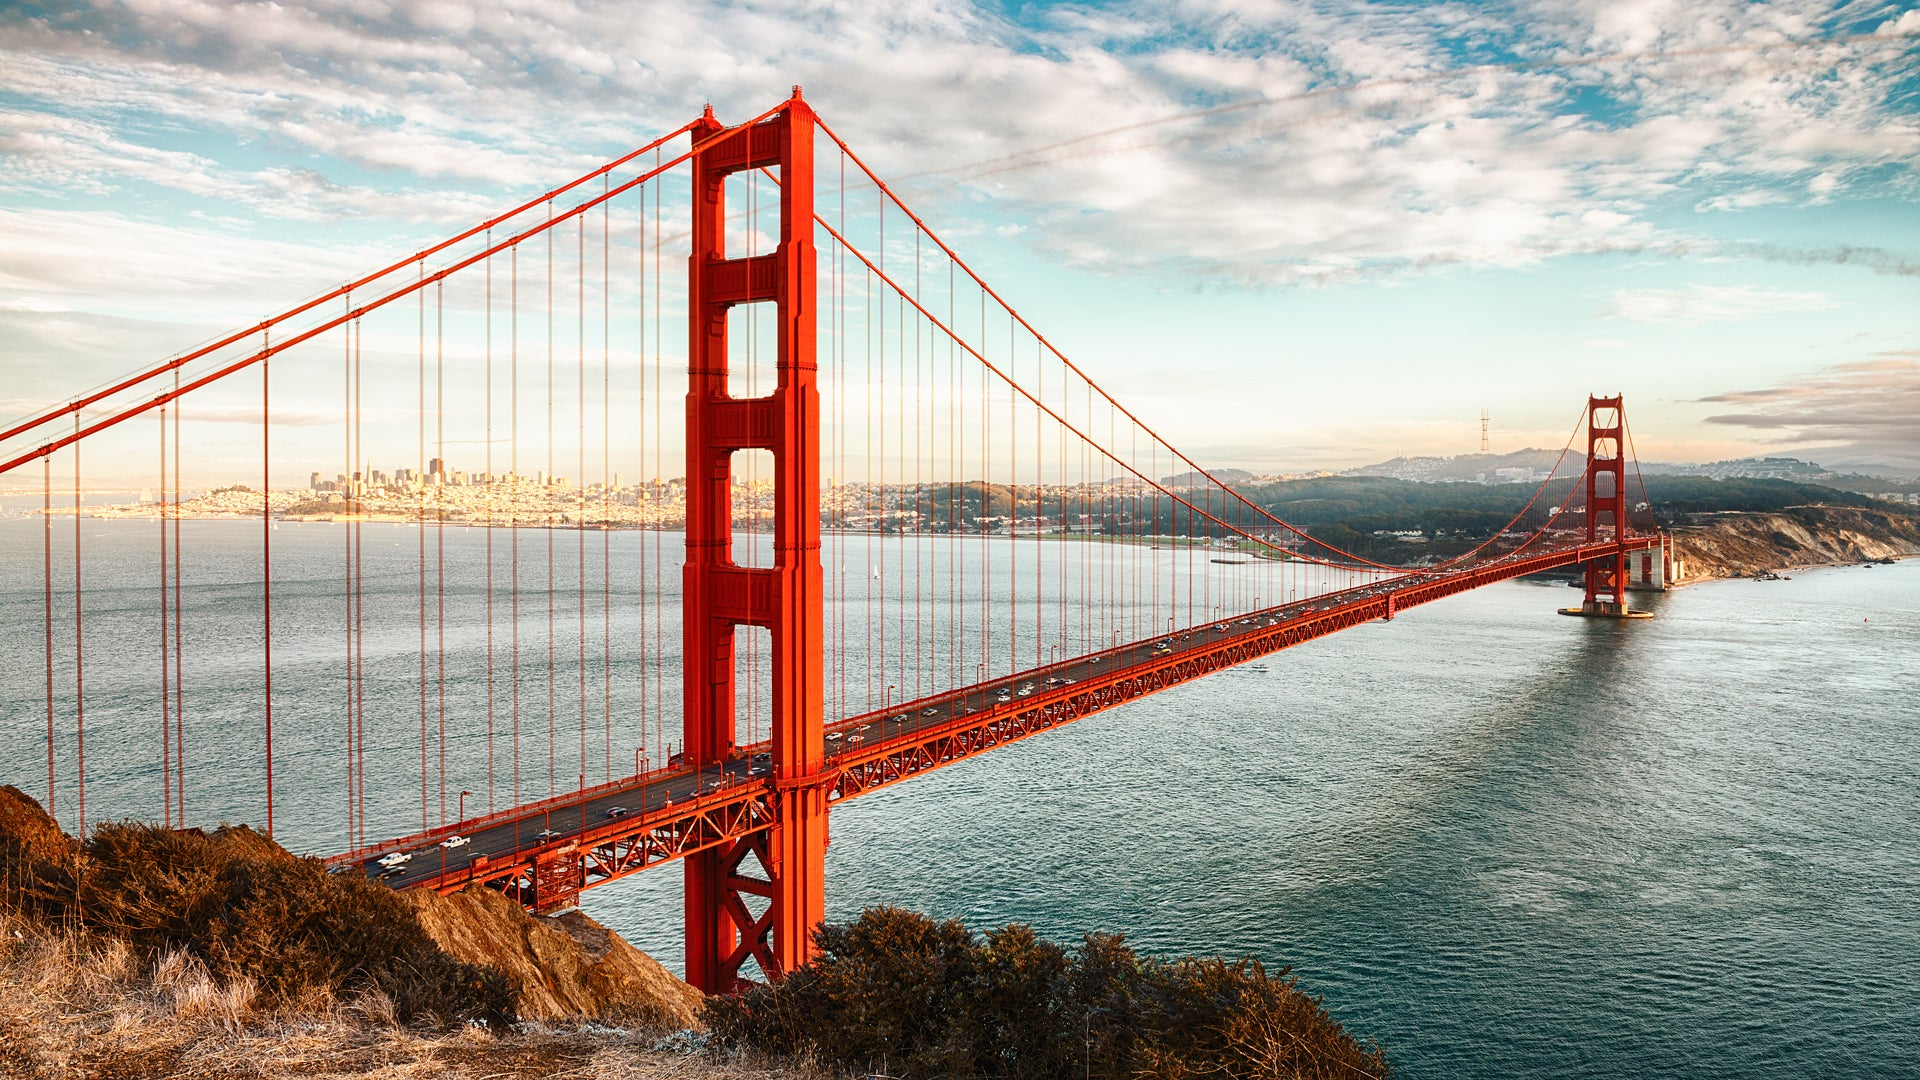How does the use of color contribute to the impact of this image? The use of color in the image is striking and contributes significantly to its impact. The vivid red of the Golden Gate Bridge stands out boldly against the tranquil blues of the sky and water. This contrast not only highlights the bridge's architectural beauty but also draws the viewer's eye immediately to the central feature of the image. The natural colors of the surrounding landscape and the subtle hues of the city in the background create a harmonious balance, enhancing the overall visual appeal. The strategic use of color accentuates the bridge's iconic status and invites prolonged appreciation. 